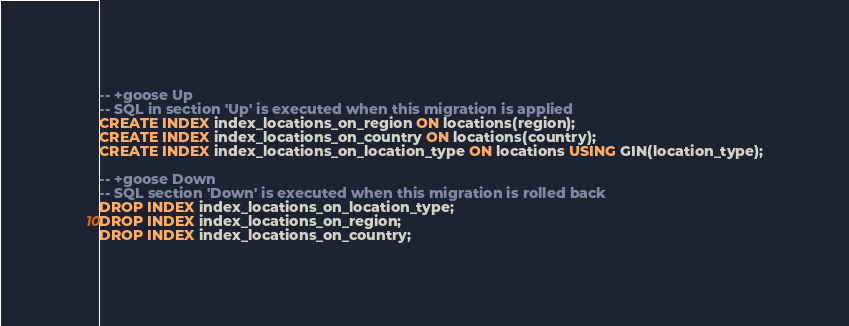Convert code to text. <code><loc_0><loc_0><loc_500><loc_500><_SQL_>
-- +goose Up
-- SQL in section 'Up' is executed when this migration is applied
CREATE INDEX index_locations_on_region ON locations(region);
CREATE INDEX index_locations_on_country ON locations(country);
CREATE INDEX index_locations_on_location_type ON locations USING GIN(location_type);

-- +goose Down
-- SQL section 'Down' is executed when this migration is rolled back
DROP INDEX index_locations_on_location_type;
DROP INDEX index_locations_on_region;
DROP INDEX index_locations_on_country;
</code> 